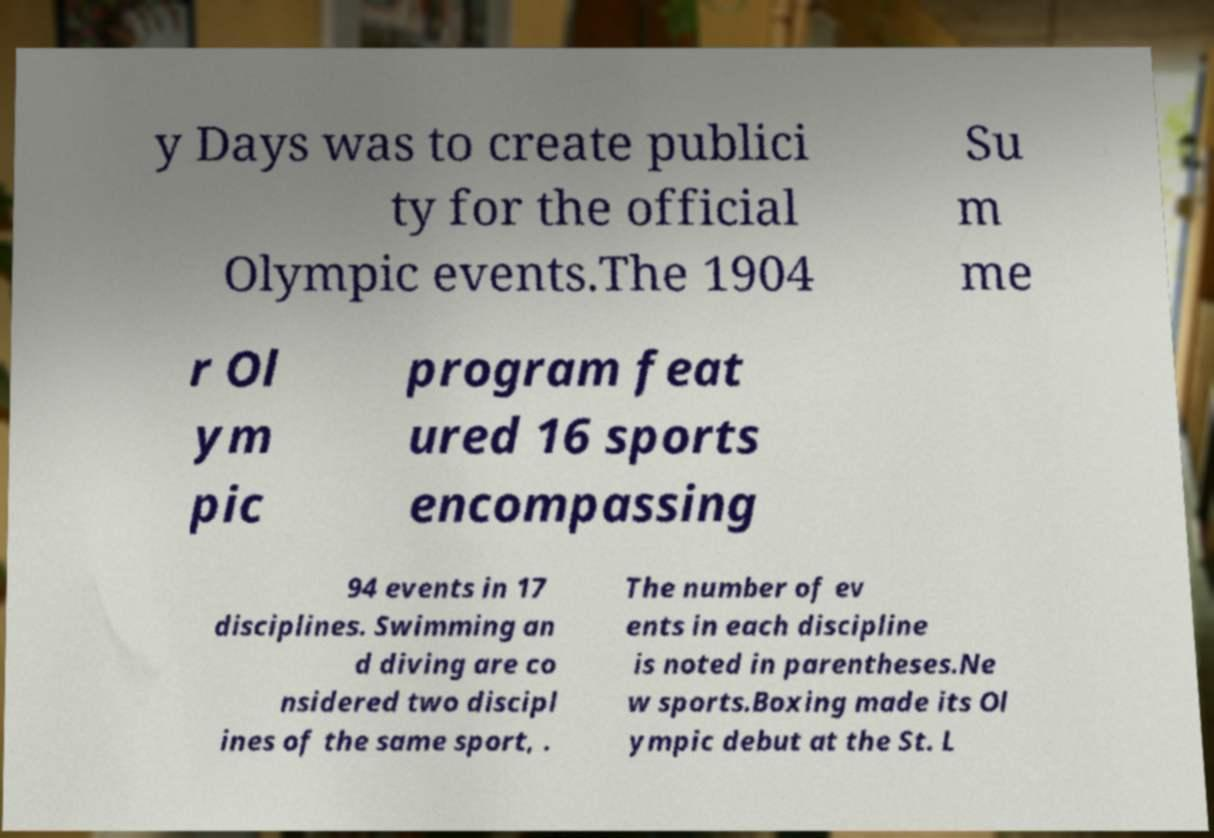For documentation purposes, I need the text within this image transcribed. Could you provide that? y Days was to create publici ty for the official Olympic events.The 1904 Su m me r Ol ym pic program feat ured 16 sports encompassing 94 events in 17 disciplines. Swimming an d diving are co nsidered two discipl ines of the same sport, . The number of ev ents in each discipline is noted in parentheses.Ne w sports.Boxing made its Ol ympic debut at the St. L 